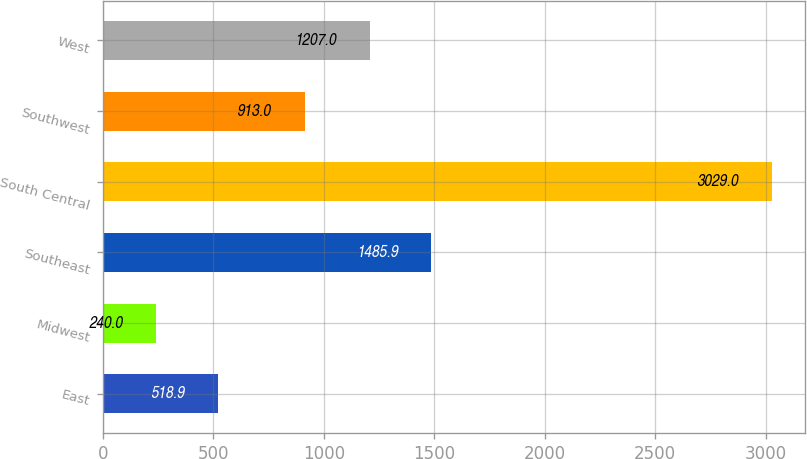Convert chart. <chart><loc_0><loc_0><loc_500><loc_500><bar_chart><fcel>East<fcel>Midwest<fcel>Southeast<fcel>South Central<fcel>Southwest<fcel>West<nl><fcel>518.9<fcel>240<fcel>1485.9<fcel>3029<fcel>913<fcel>1207<nl></chart> 